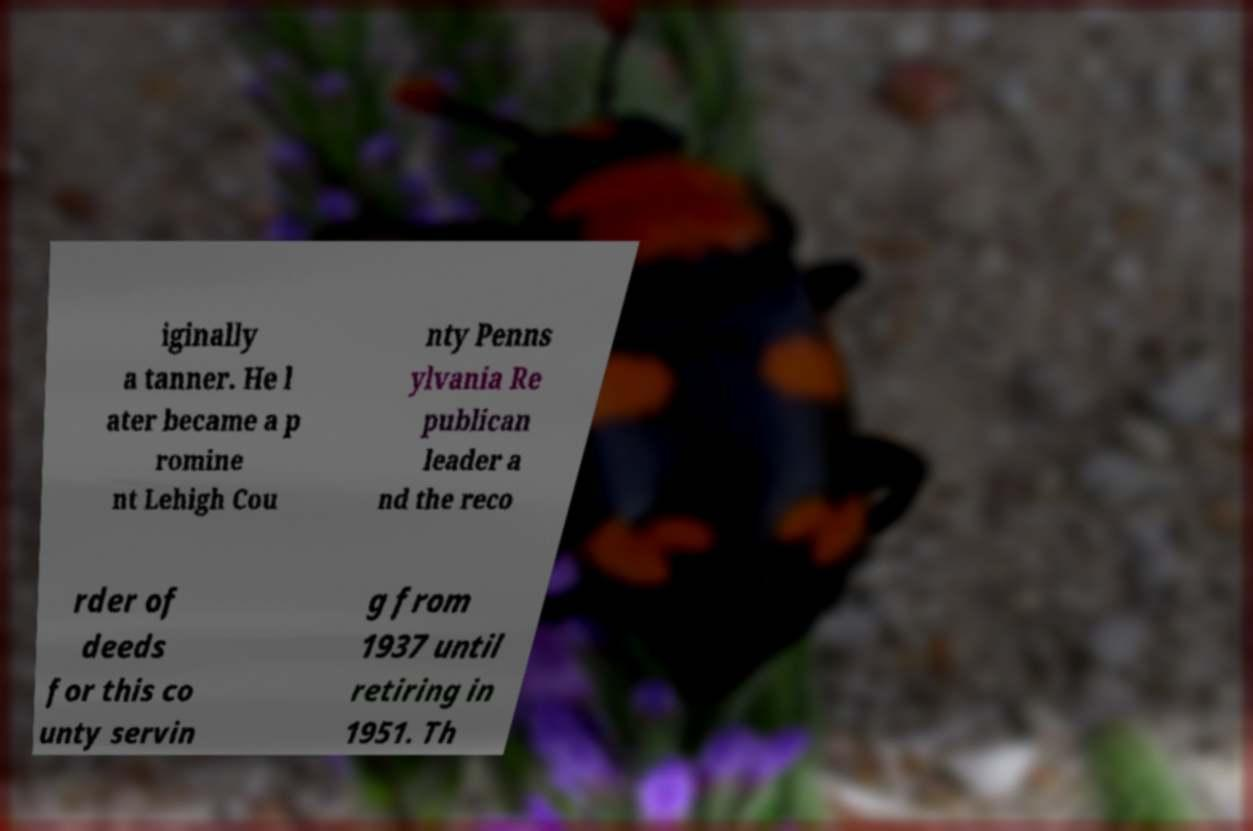What messages or text are displayed in this image? I need them in a readable, typed format. iginally a tanner. He l ater became a p romine nt Lehigh Cou nty Penns ylvania Re publican leader a nd the reco rder of deeds for this co unty servin g from 1937 until retiring in 1951. Th 